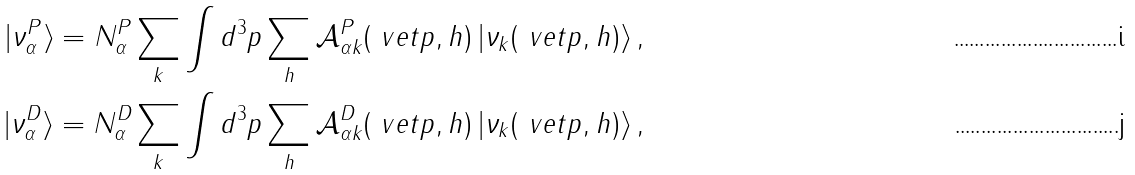Convert formula to latex. <formula><loc_0><loc_0><loc_500><loc_500>| \nu _ { \alpha } ^ { P } \rangle = N _ { \alpha } ^ { P } \sum _ { k } \int d ^ { 3 } p \sum _ { h } \mathcal { A } _ { \alpha k } ^ { P } ( \ v e t { p } , h ) \, | \nu _ { k } ( \ v e t { p } , h ) \rangle \, , \\ | \nu _ { \alpha } ^ { D } \rangle = N _ { \alpha } ^ { D } \sum _ { k } \int d ^ { 3 } p \sum _ { h } \mathcal { A } _ { \alpha k } ^ { D } ( \ v e t { p } , h ) \, | \nu _ { k } ( \ v e t { p } , h ) \rangle \, ,</formula> 